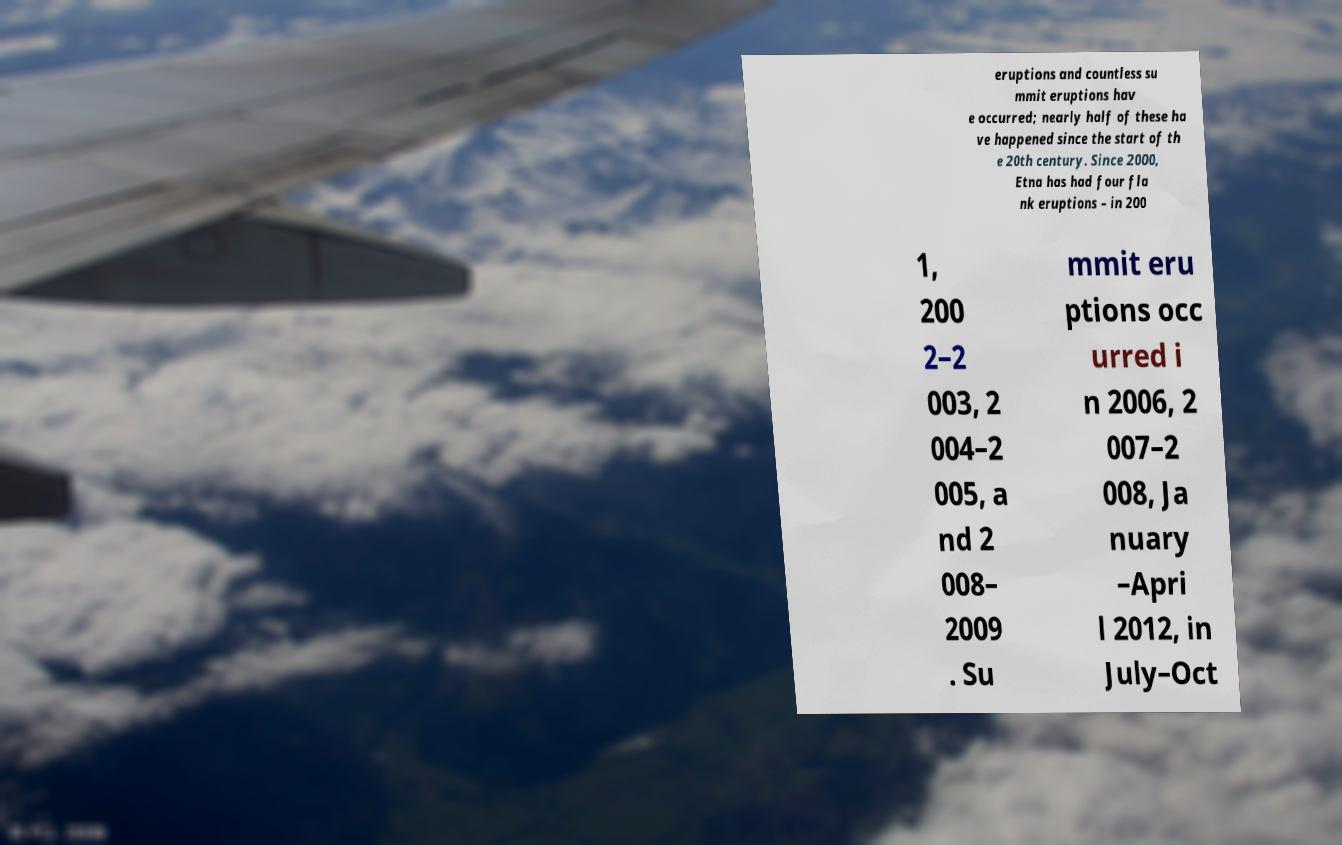There's text embedded in this image that I need extracted. Can you transcribe it verbatim? eruptions and countless su mmit eruptions hav e occurred; nearly half of these ha ve happened since the start of th e 20th century. Since 2000, Etna has had four fla nk eruptions – in 200 1, 200 2–2 003, 2 004–2 005, a nd 2 008– 2009 . Su mmit eru ptions occ urred i n 2006, 2 007–2 008, Ja nuary –Apri l 2012, in July–Oct 